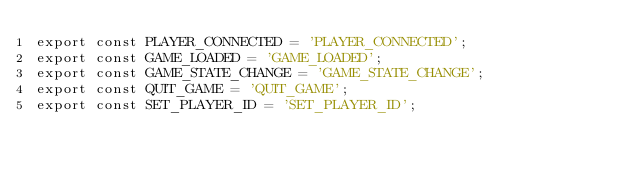<code> <loc_0><loc_0><loc_500><loc_500><_TypeScript_>export const PLAYER_CONNECTED = 'PLAYER_CONNECTED';
export const GAME_LOADED = 'GAME_LOADED';
export const GAME_STATE_CHANGE = 'GAME_STATE_CHANGE';
export const QUIT_GAME = 'QUIT_GAME';
export const SET_PLAYER_ID = 'SET_PLAYER_ID';</code> 